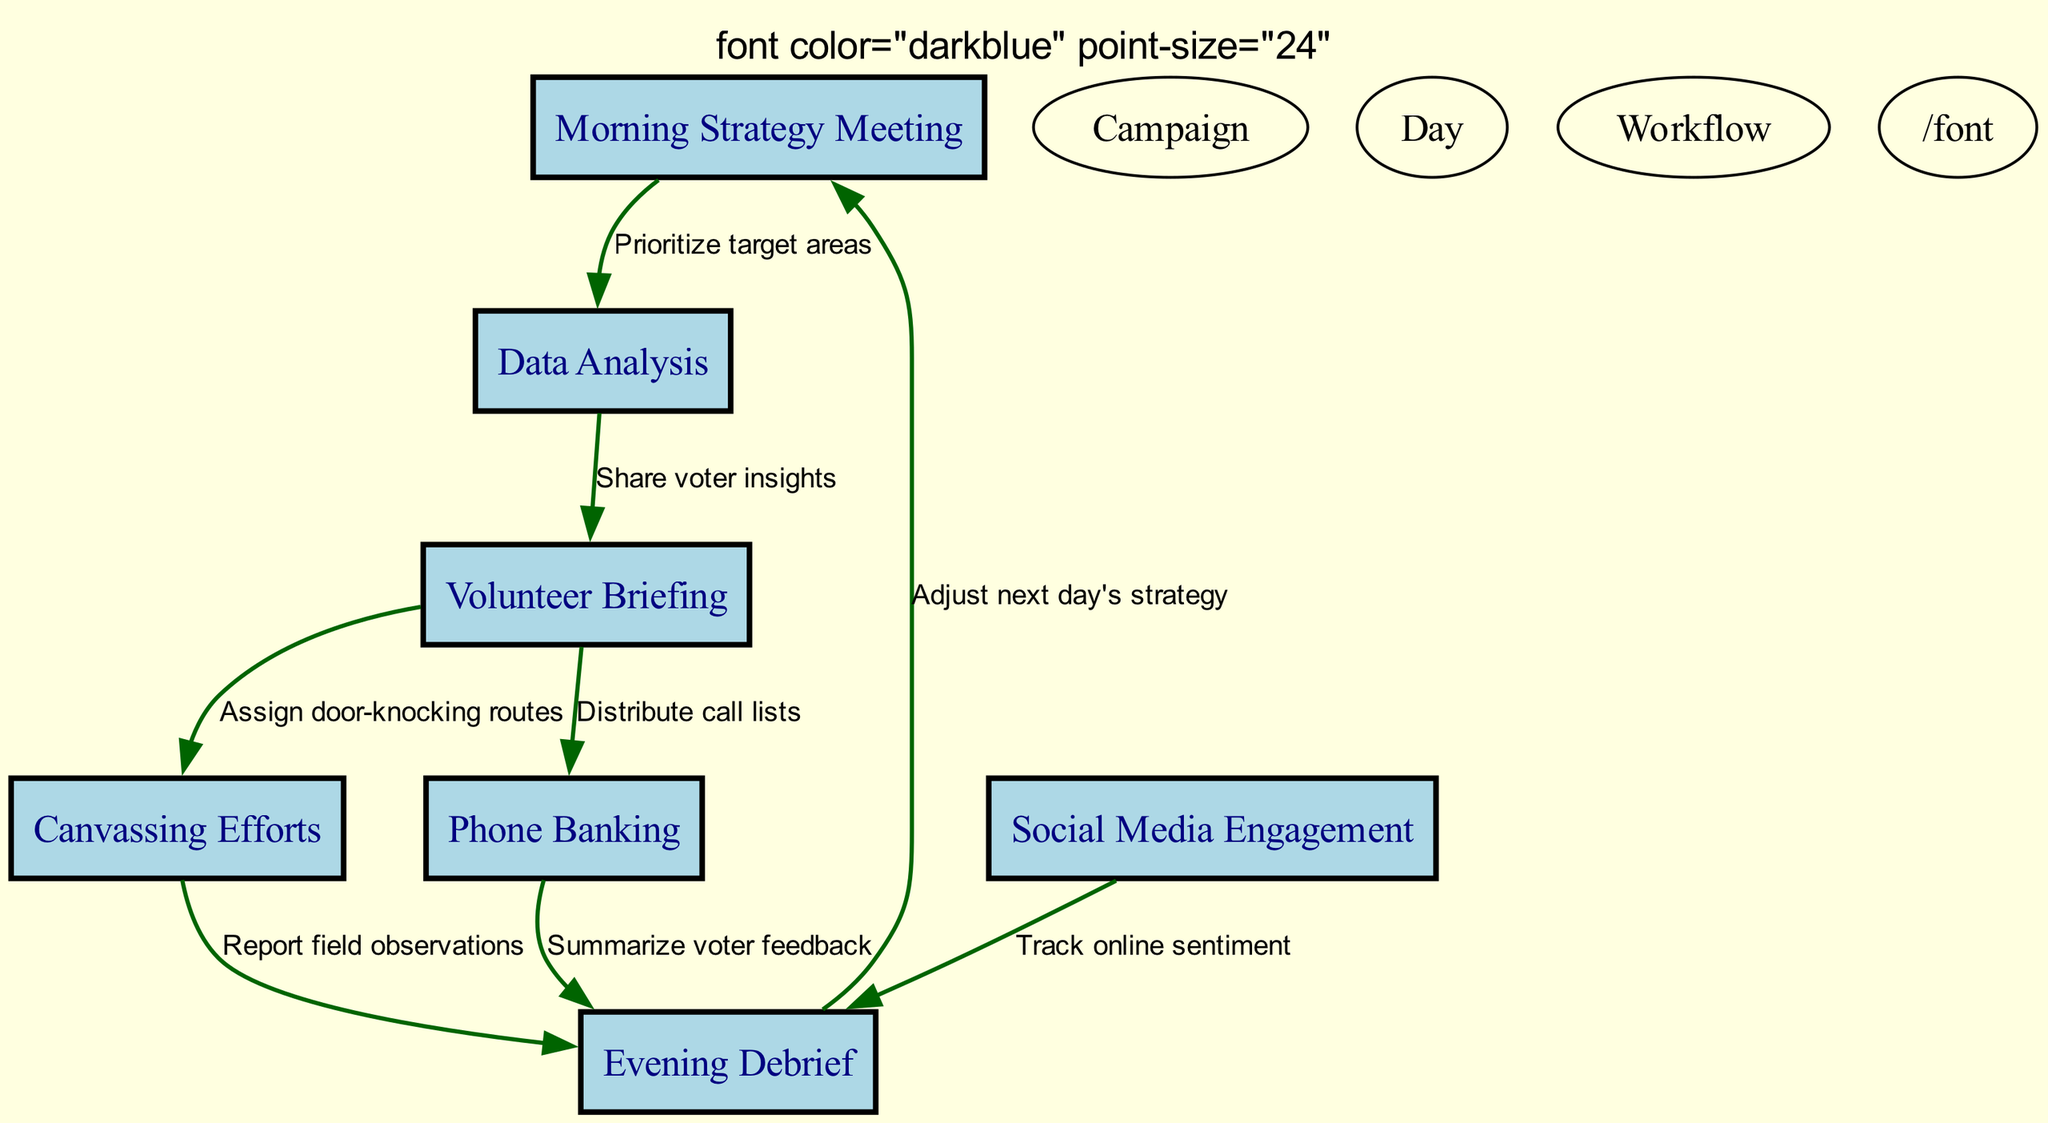What is the first step in the campaign workflow? The first node in the diagram is "Morning Strategy Meeting," indicating it is the starting point.
Answer: Morning Strategy Meeting How many nodes are there in the workflow? By counting the distinct nodes shown in the diagram, we identify a total of seven nodes representing various activities.
Answer: 7 What is the result of Data Analysis? "Data Analysis" leads to "Volunteer Briefing" and is connected by the label "Share voter insights," showing the direct outcome of this node.
Answer: Share voter insights Which activity follows the Volunteer Briefing? The arrow from "Volunteer Briefing" points towards "Canvassing Efforts," indicating that canvassing immediately follows the briefing.
Answer: Canvassing Efforts What do canvassing efforts report during the Evening Debrief? The "Canvassing Efforts" node connects to the "Evening Debrief" via the label "Report field observations," indicating the feedback reported during debriefing.
Answer: Report field observations How many paths directly lead to the Evening Debrief? By examining the edges leading to the "Evening Debrief" node, we find three distinct incoming connections: from "Canvassing Efforts," "Phone Banking," and "Social Media Engagement."
Answer: 3 What is the last action taken to adjust the strategy for the next day? The "Evening Debrief" connects back to the "Morning Strategy Meeting" with the label "Adjust next day's strategy," indicating the last action.
Answer: Adjust next day's strategy Which type of engagement comes before Phone Banking? The direct edge leading to "Phone Banking" comes from "Volunteer Briefing," indicating that briefing is a prerequisite for phone banking.
Answer: Volunteer Briefing What does Social Media Engagement track? The edge from "Social Media Engagement" to "Evening Debrief" is labeled "Track online sentiment," indicating what is tracked through this activity.
Answer: Track online sentiment 